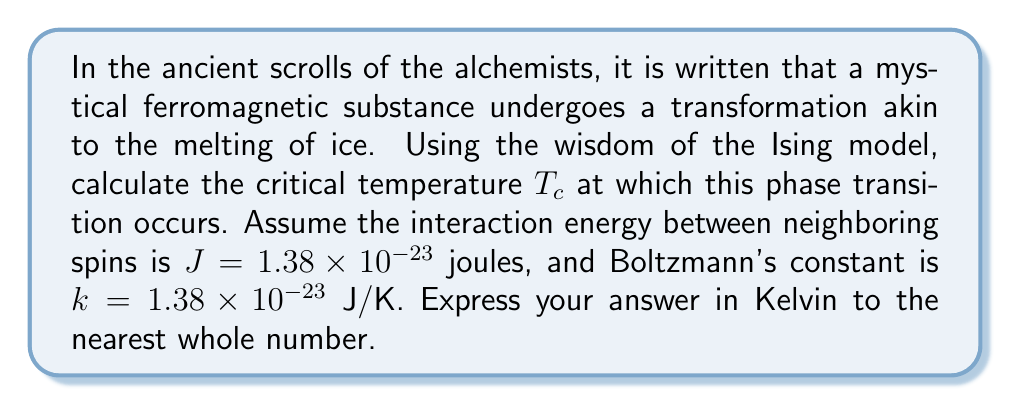Give your solution to this math problem. 1. The Ising model describes ferromagnetic materials as a lattice of spins that can be either up or down.

2. In the two-dimensional Ising model, the critical temperature $T_c$ is given by the exact solution:

   $$T_c = \frac{2J}{k \ln(1 + \sqrt{2})}$$

3. We are given:
   $J = 1.38 \times 10^{-23}$ joules
   $k = 1.38 \times 10^{-23}$ J/K

4. Let us calculate $\ln(1 + \sqrt{2})$:
   $$\ln(1 + \sqrt{2}) \approx 0.8814$$

5. Now, substitute the values into the equation:

   $$T_c = \frac{2 \times (1.38 \times 10^{-23})}{(1.38 \times 10^{-23}) \times 0.8814}$$

6. The units of $J$ and $k$ cancel out, leaving us with Kelvin:

   $$T_c = \frac{2}{0.8814} \approx 2.2692 \text{ K}$$

7. Rounding to the nearest whole number:

   $$T_c \approx 2 \text{ K}$$
Answer: 2 K 